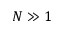<formula> <loc_0><loc_0><loc_500><loc_500>N \gg 1</formula> 